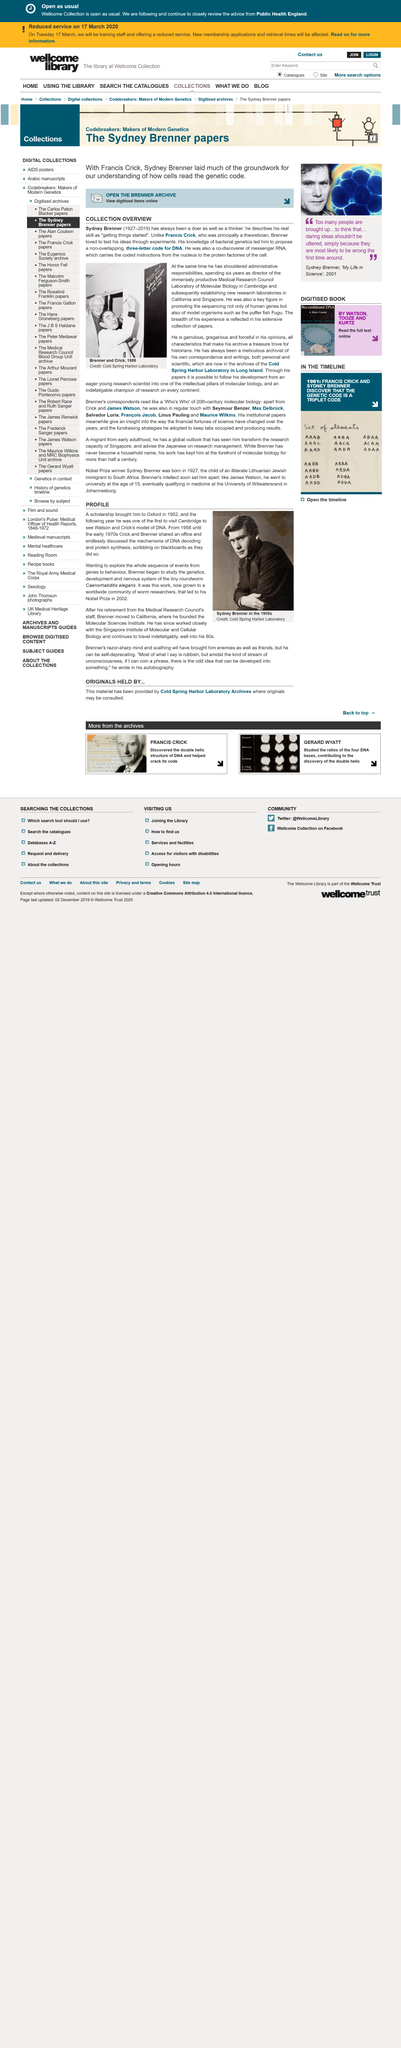Indicate a few pertinent items in this graphic. On the 30th of July 1986, the image on the left was taken. The person went to Oxford in 1952. The person got a scholarship to Oxford. Sydney Brenner was the director of the Medical Research Council Laboratory of Molecular Biology in Cambridge for a period of 6 years. Sydney Brenner died in 2019. 